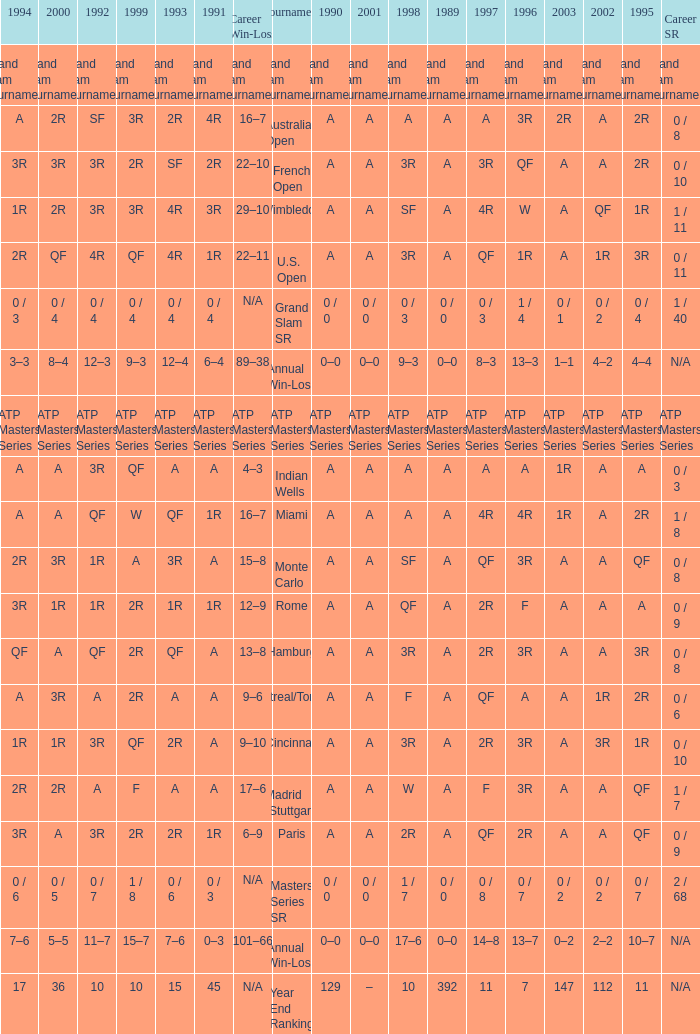What is the value in 1997 when the value in 1989 is A, 1995 is QF, 1996 is 3R and the career SR is 0 / 8? QF. 